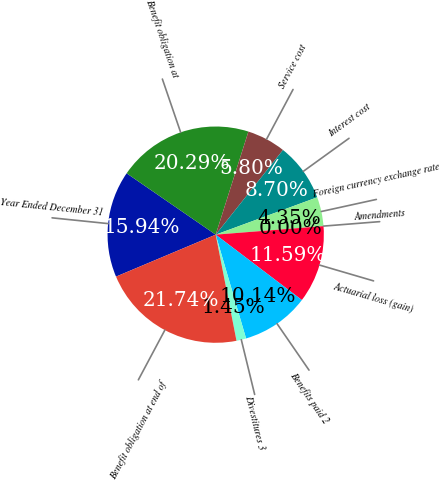Convert chart to OTSL. <chart><loc_0><loc_0><loc_500><loc_500><pie_chart><fcel>Year Ended December 31<fcel>Benefit obligation at<fcel>Service cost<fcel>Interest cost<fcel>Foreign currency exchange rate<fcel>Amendments<fcel>Actuarial loss (gain)<fcel>Benefits paid 2<fcel>Divestitures 3<fcel>Benefit obligation at end of<nl><fcel>15.94%<fcel>20.29%<fcel>5.8%<fcel>8.7%<fcel>4.35%<fcel>0.0%<fcel>11.59%<fcel>10.14%<fcel>1.45%<fcel>21.74%<nl></chart> 